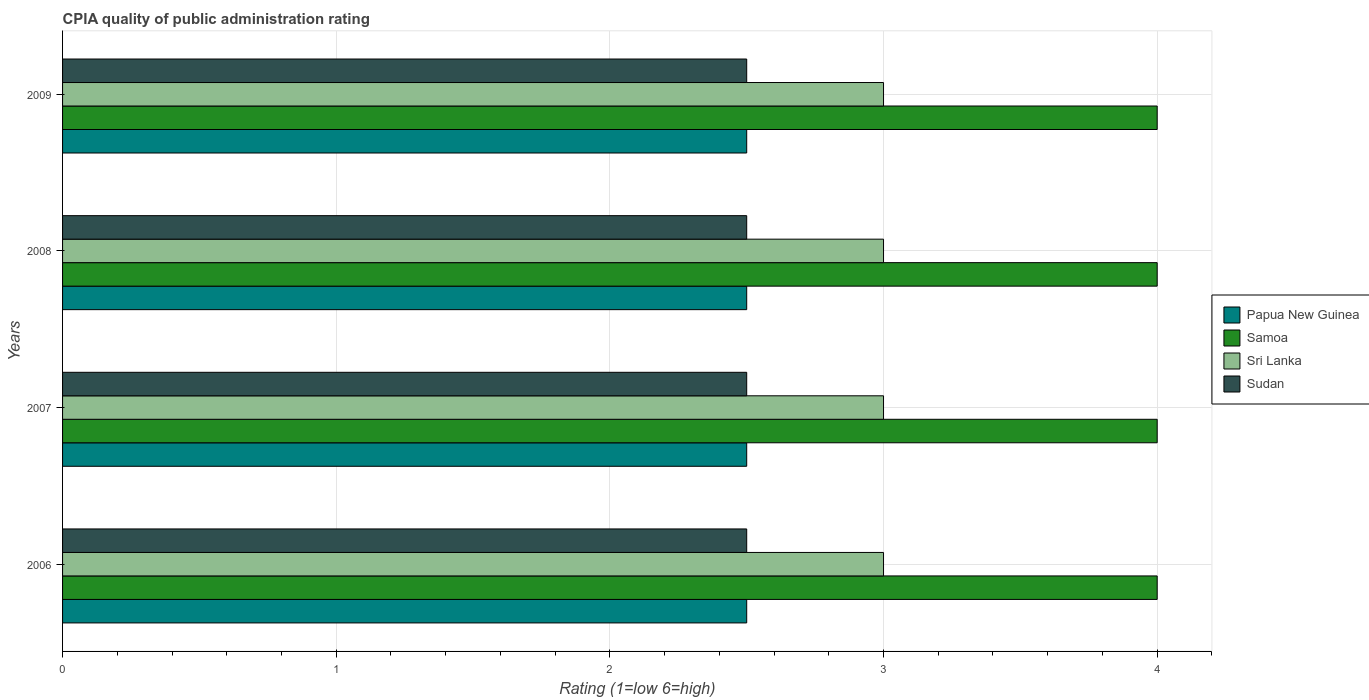How many bars are there on the 3rd tick from the bottom?
Offer a terse response. 4. In how many cases, is the number of bars for a given year not equal to the number of legend labels?
Give a very brief answer. 0. Across all years, what is the maximum CPIA rating in Sri Lanka?
Provide a succinct answer. 3. In which year was the CPIA rating in Samoa maximum?
Your answer should be very brief. 2006. What is the total CPIA rating in Sudan in the graph?
Your response must be concise. 10. What is the difference between the CPIA rating in Sudan in 2008 and that in 2009?
Provide a short and direct response. 0. What is the average CPIA rating in Sri Lanka per year?
Keep it short and to the point. 3. In the year 2008, what is the difference between the CPIA rating in Sri Lanka and CPIA rating in Samoa?
Ensure brevity in your answer.  -1. In how many years, is the CPIA rating in Samoa greater than 2.4 ?
Your response must be concise. 4. What is the ratio of the CPIA rating in Sudan in 2006 to that in 2009?
Provide a short and direct response. 1. Is the difference between the CPIA rating in Sri Lanka in 2007 and 2009 greater than the difference between the CPIA rating in Samoa in 2007 and 2009?
Make the answer very short. No. What is the difference between the highest and the lowest CPIA rating in Sri Lanka?
Make the answer very short. 0. In how many years, is the CPIA rating in Sri Lanka greater than the average CPIA rating in Sri Lanka taken over all years?
Provide a succinct answer. 0. Is the sum of the CPIA rating in Samoa in 2007 and 2009 greater than the maximum CPIA rating in Sudan across all years?
Your answer should be compact. Yes. Is it the case that in every year, the sum of the CPIA rating in Sri Lanka and CPIA rating in Papua New Guinea is greater than the sum of CPIA rating in Sudan and CPIA rating in Samoa?
Keep it short and to the point. No. What does the 2nd bar from the top in 2009 represents?
Offer a very short reply. Sri Lanka. What does the 2nd bar from the bottom in 2008 represents?
Make the answer very short. Samoa. Is it the case that in every year, the sum of the CPIA rating in Sri Lanka and CPIA rating in Samoa is greater than the CPIA rating in Papua New Guinea?
Your answer should be very brief. Yes. How many bars are there?
Make the answer very short. 16. Are all the bars in the graph horizontal?
Make the answer very short. Yes. How many years are there in the graph?
Give a very brief answer. 4. Are the values on the major ticks of X-axis written in scientific E-notation?
Offer a terse response. No. Does the graph contain grids?
Make the answer very short. Yes. How are the legend labels stacked?
Give a very brief answer. Vertical. What is the title of the graph?
Give a very brief answer. CPIA quality of public administration rating. Does "Mali" appear as one of the legend labels in the graph?
Your answer should be very brief. No. What is the Rating (1=low 6=high) in Papua New Guinea in 2006?
Give a very brief answer. 2.5. What is the Rating (1=low 6=high) in Samoa in 2006?
Offer a very short reply. 4. What is the Rating (1=low 6=high) of Samoa in 2007?
Ensure brevity in your answer.  4. What is the Rating (1=low 6=high) in Sri Lanka in 2008?
Ensure brevity in your answer.  3. What is the Rating (1=low 6=high) in Sudan in 2008?
Provide a succinct answer. 2.5. What is the Rating (1=low 6=high) of Papua New Guinea in 2009?
Your answer should be very brief. 2.5. Across all years, what is the maximum Rating (1=low 6=high) in Papua New Guinea?
Provide a short and direct response. 2.5. Across all years, what is the maximum Rating (1=low 6=high) of Samoa?
Keep it short and to the point. 4. Across all years, what is the maximum Rating (1=low 6=high) in Sri Lanka?
Provide a succinct answer. 3. Across all years, what is the minimum Rating (1=low 6=high) of Sudan?
Keep it short and to the point. 2.5. What is the difference between the Rating (1=low 6=high) in Sri Lanka in 2006 and that in 2007?
Your answer should be compact. 0. What is the difference between the Rating (1=low 6=high) of Papua New Guinea in 2006 and that in 2008?
Offer a terse response. 0. What is the difference between the Rating (1=low 6=high) in Samoa in 2006 and that in 2008?
Keep it short and to the point. 0. What is the difference between the Rating (1=low 6=high) of Sri Lanka in 2006 and that in 2008?
Give a very brief answer. 0. What is the difference between the Rating (1=low 6=high) in Papua New Guinea in 2006 and that in 2009?
Provide a short and direct response. 0. What is the difference between the Rating (1=low 6=high) in Samoa in 2006 and that in 2009?
Your response must be concise. 0. What is the difference between the Rating (1=low 6=high) in Sri Lanka in 2006 and that in 2009?
Your response must be concise. 0. What is the difference between the Rating (1=low 6=high) in Sudan in 2006 and that in 2009?
Offer a terse response. 0. What is the difference between the Rating (1=low 6=high) in Samoa in 2007 and that in 2008?
Offer a very short reply. 0. What is the difference between the Rating (1=low 6=high) of Papua New Guinea in 2007 and that in 2009?
Offer a terse response. 0. What is the difference between the Rating (1=low 6=high) of Samoa in 2007 and that in 2009?
Your answer should be compact. 0. What is the difference between the Rating (1=low 6=high) in Sri Lanka in 2007 and that in 2009?
Make the answer very short. 0. What is the difference between the Rating (1=low 6=high) of Sri Lanka in 2008 and that in 2009?
Offer a very short reply. 0. What is the difference between the Rating (1=low 6=high) of Papua New Guinea in 2006 and the Rating (1=low 6=high) of Samoa in 2007?
Make the answer very short. -1.5. What is the difference between the Rating (1=low 6=high) of Papua New Guinea in 2006 and the Rating (1=low 6=high) of Sri Lanka in 2007?
Offer a very short reply. -0.5. What is the difference between the Rating (1=low 6=high) in Samoa in 2006 and the Rating (1=low 6=high) in Sudan in 2007?
Keep it short and to the point. 1.5. What is the difference between the Rating (1=low 6=high) in Sri Lanka in 2006 and the Rating (1=low 6=high) in Sudan in 2007?
Give a very brief answer. 0.5. What is the difference between the Rating (1=low 6=high) of Papua New Guinea in 2006 and the Rating (1=low 6=high) of Sudan in 2008?
Offer a terse response. 0. What is the difference between the Rating (1=low 6=high) of Samoa in 2006 and the Rating (1=low 6=high) of Sri Lanka in 2008?
Make the answer very short. 1. What is the difference between the Rating (1=low 6=high) of Papua New Guinea in 2006 and the Rating (1=low 6=high) of Samoa in 2009?
Your answer should be compact. -1.5. What is the difference between the Rating (1=low 6=high) of Papua New Guinea in 2006 and the Rating (1=low 6=high) of Sudan in 2009?
Keep it short and to the point. 0. What is the difference between the Rating (1=low 6=high) in Samoa in 2006 and the Rating (1=low 6=high) in Sri Lanka in 2009?
Make the answer very short. 1. What is the difference between the Rating (1=low 6=high) in Sri Lanka in 2006 and the Rating (1=low 6=high) in Sudan in 2009?
Your answer should be compact. 0.5. What is the difference between the Rating (1=low 6=high) in Papua New Guinea in 2007 and the Rating (1=low 6=high) in Sri Lanka in 2008?
Ensure brevity in your answer.  -0.5. What is the difference between the Rating (1=low 6=high) of Papua New Guinea in 2007 and the Rating (1=low 6=high) of Sudan in 2008?
Ensure brevity in your answer.  0. What is the difference between the Rating (1=low 6=high) in Samoa in 2007 and the Rating (1=low 6=high) in Sri Lanka in 2008?
Ensure brevity in your answer.  1. What is the difference between the Rating (1=low 6=high) in Papua New Guinea in 2007 and the Rating (1=low 6=high) in Sri Lanka in 2009?
Provide a short and direct response. -0.5. What is the difference between the Rating (1=low 6=high) of Papua New Guinea in 2007 and the Rating (1=low 6=high) of Sudan in 2009?
Ensure brevity in your answer.  0. What is the difference between the Rating (1=low 6=high) of Samoa in 2007 and the Rating (1=low 6=high) of Sudan in 2009?
Give a very brief answer. 1.5. What is the difference between the Rating (1=low 6=high) of Papua New Guinea in 2008 and the Rating (1=low 6=high) of Samoa in 2009?
Offer a terse response. -1.5. What is the difference between the Rating (1=low 6=high) in Papua New Guinea in 2008 and the Rating (1=low 6=high) in Sri Lanka in 2009?
Offer a terse response. -0.5. What is the difference between the Rating (1=low 6=high) in Samoa in 2008 and the Rating (1=low 6=high) in Sri Lanka in 2009?
Your answer should be very brief. 1. What is the average Rating (1=low 6=high) of Papua New Guinea per year?
Make the answer very short. 2.5. What is the average Rating (1=low 6=high) of Samoa per year?
Your answer should be compact. 4. What is the average Rating (1=low 6=high) in Sri Lanka per year?
Your answer should be compact. 3. What is the average Rating (1=low 6=high) in Sudan per year?
Offer a terse response. 2.5. In the year 2006, what is the difference between the Rating (1=low 6=high) of Papua New Guinea and Rating (1=low 6=high) of Sudan?
Your answer should be compact. 0. In the year 2007, what is the difference between the Rating (1=low 6=high) in Papua New Guinea and Rating (1=low 6=high) in Samoa?
Offer a very short reply. -1.5. In the year 2007, what is the difference between the Rating (1=low 6=high) in Papua New Guinea and Rating (1=low 6=high) in Sri Lanka?
Give a very brief answer. -0.5. In the year 2007, what is the difference between the Rating (1=low 6=high) of Papua New Guinea and Rating (1=low 6=high) of Sudan?
Offer a very short reply. 0. In the year 2007, what is the difference between the Rating (1=low 6=high) of Samoa and Rating (1=low 6=high) of Sri Lanka?
Offer a very short reply. 1. In the year 2007, what is the difference between the Rating (1=low 6=high) in Samoa and Rating (1=low 6=high) in Sudan?
Make the answer very short. 1.5. In the year 2008, what is the difference between the Rating (1=low 6=high) in Papua New Guinea and Rating (1=low 6=high) in Sri Lanka?
Provide a succinct answer. -0.5. In the year 2008, what is the difference between the Rating (1=low 6=high) of Papua New Guinea and Rating (1=low 6=high) of Sudan?
Make the answer very short. 0. In the year 2009, what is the difference between the Rating (1=low 6=high) of Papua New Guinea and Rating (1=low 6=high) of Samoa?
Your answer should be very brief. -1.5. In the year 2009, what is the difference between the Rating (1=low 6=high) in Papua New Guinea and Rating (1=low 6=high) in Sri Lanka?
Your response must be concise. -0.5. In the year 2009, what is the difference between the Rating (1=low 6=high) of Sri Lanka and Rating (1=low 6=high) of Sudan?
Provide a succinct answer. 0.5. What is the ratio of the Rating (1=low 6=high) in Papua New Guinea in 2006 to that in 2007?
Make the answer very short. 1. What is the ratio of the Rating (1=low 6=high) in Samoa in 2006 to that in 2007?
Your response must be concise. 1. What is the ratio of the Rating (1=low 6=high) in Sri Lanka in 2006 to that in 2007?
Your response must be concise. 1. What is the ratio of the Rating (1=low 6=high) of Papua New Guinea in 2006 to that in 2008?
Provide a short and direct response. 1. What is the ratio of the Rating (1=low 6=high) in Papua New Guinea in 2007 to that in 2008?
Give a very brief answer. 1. What is the ratio of the Rating (1=low 6=high) in Samoa in 2007 to that in 2008?
Keep it short and to the point. 1. What is the ratio of the Rating (1=low 6=high) of Sudan in 2007 to that in 2008?
Provide a succinct answer. 1. What is the ratio of the Rating (1=low 6=high) of Papua New Guinea in 2007 to that in 2009?
Your answer should be compact. 1. What is the ratio of the Rating (1=low 6=high) of Samoa in 2007 to that in 2009?
Offer a very short reply. 1. What is the ratio of the Rating (1=low 6=high) in Sudan in 2007 to that in 2009?
Offer a terse response. 1. What is the difference between the highest and the second highest Rating (1=low 6=high) of Papua New Guinea?
Make the answer very short. 0. What is the difference between the highest and the second highest Rating (1=low 6=high) in Samoa?
Provide a short and direct response. 0. What is the difference between the highest and the lowest Rating (1=low 6=high) of Sudan?
Ensure brevity in your answer.  0. 